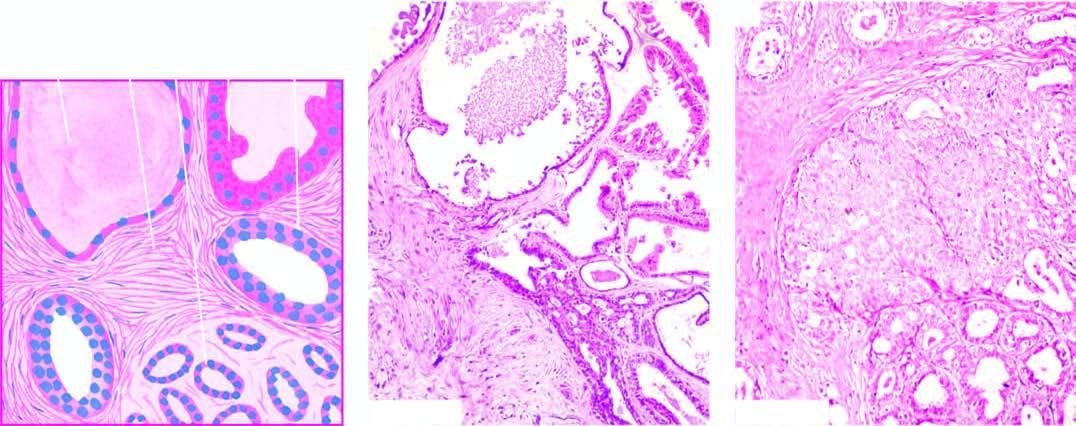s there mild epithelial hyperplasia in terminal ducts?
Answer the question using a single word or phrase. Yes 